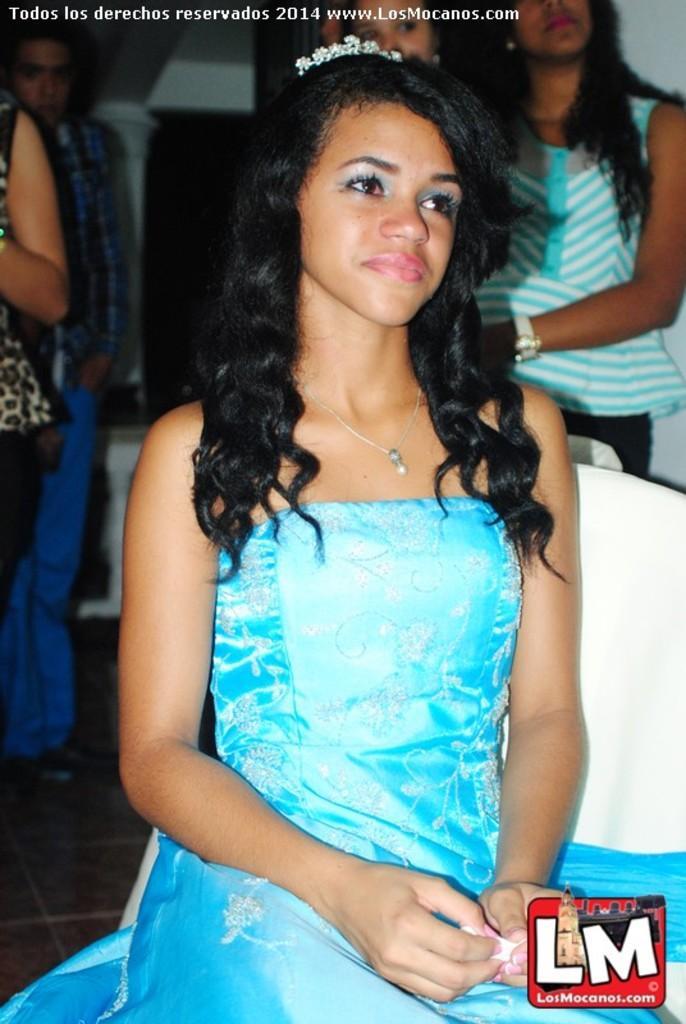How would you summarize this image in a sentence or two? In this image I can see in the middle a girl is sitting, she is wearing a blue color dress. In the right hand side bottom there is the logo. At the top there is the watermark, at the back side few persons are there. 